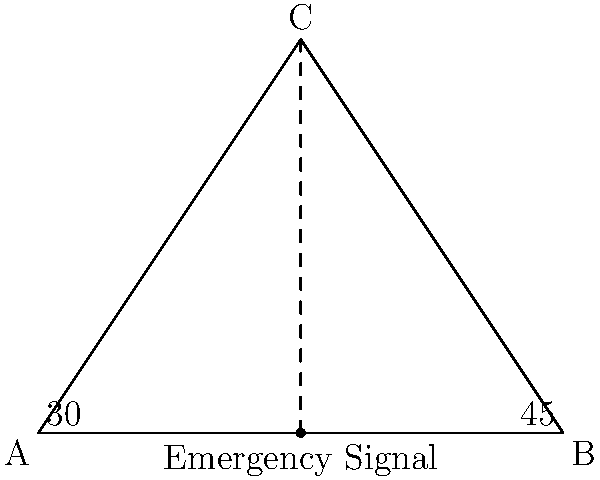Two antennas are located 8 km apart at points A and B. They detect an emergency signal, with antenna A measuring an angle of 30° and antenna B measuring an angle of 45° to the signal. What is the height (to the nearest 0.1 km) of the emergency signal location from the baseline between the two antennas? Let's approach this step-by-step:

1) The situation forms a triangle, with the two antennas at the base and the emergency signal at the apex.

2) We know the distance between the antennas (base of the triangle) is 8 km.

3) We're given two angles: 30° at A and 45° at B. The sum of angles in a triangle is 180°, so the angle at the apex (C) is:

   $180° - (30° + 45°) = 105°$

4) We can split this triangle into two right triangles by drawing a perpendicular line from C to AB.

5) Let's focus on the right triangle formed with the 30° angle. In this triangle:
   
   $\tan(30°) = \frac{\text{height}}{\text{half of base}}$

6) Half of the base is 4 km, so:

   $\text{height} = 4 \tan(30°)$

7) $\tan(30°) \approx 0.5774$

8) Therefore:

   $\text{height} \approx 4 * 0.5774 = 2.3096$ km

9) Rounding to the nearest 0.1 km gives us 2.3 km.
Answer: 2.3 km 